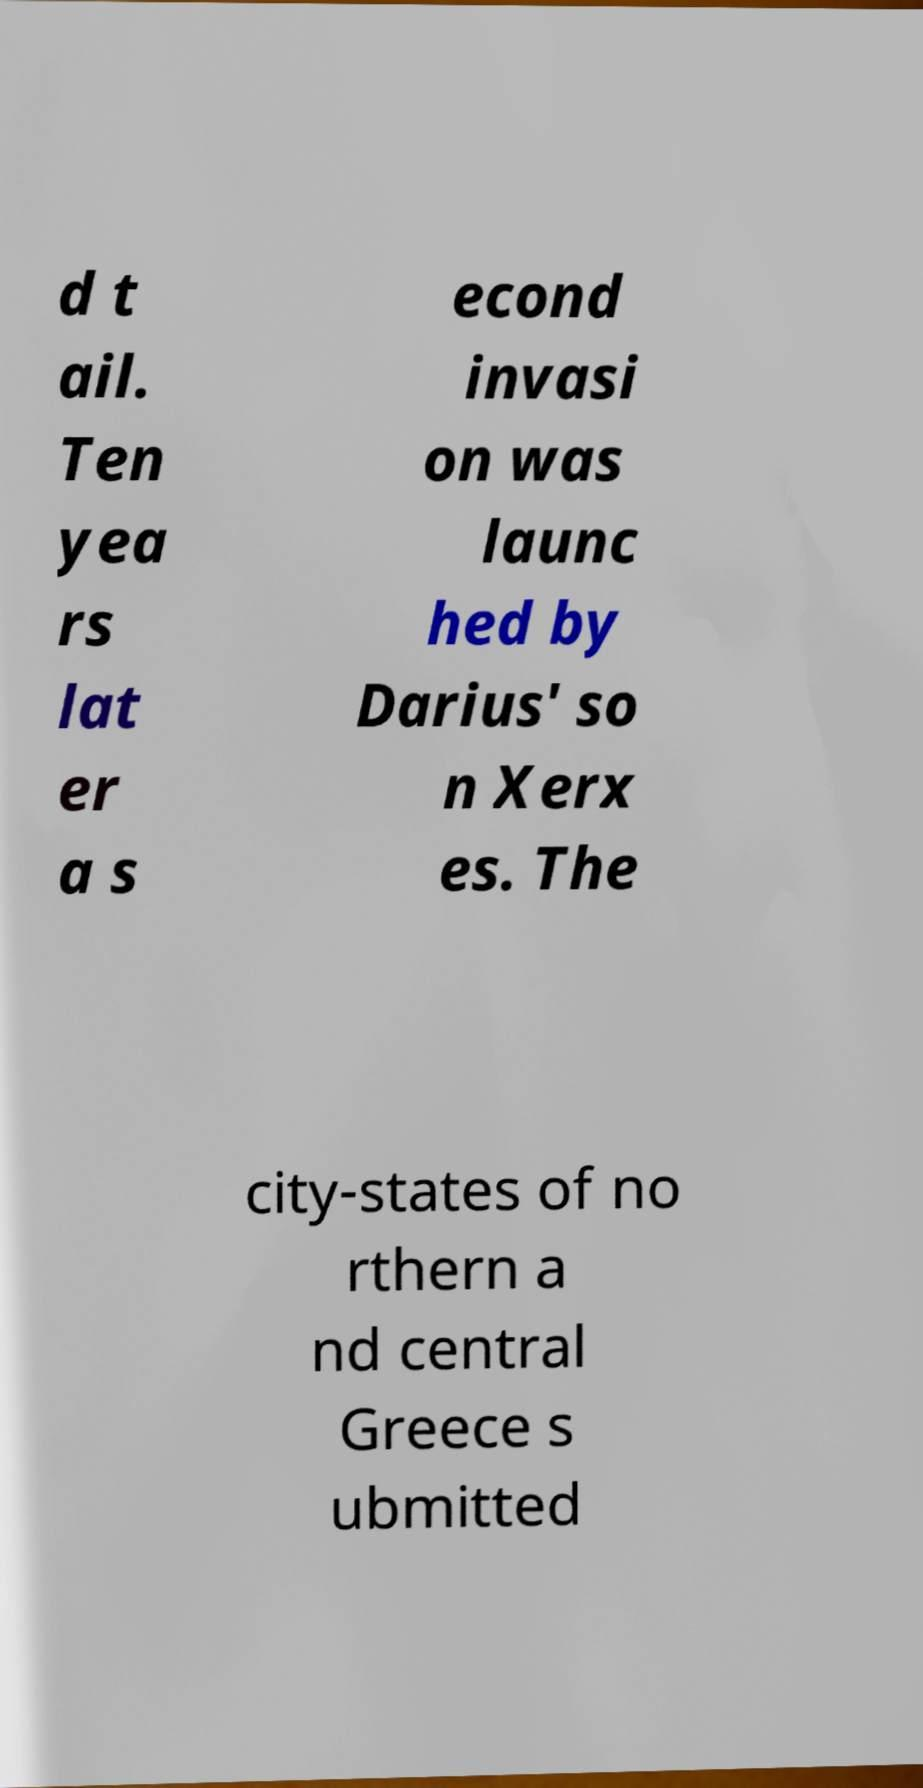What messages or text are displayed in this image? I need them in a readable, typed format. d t ail. Ten yea rs lat er a s econd invasi on was launc hed by Darius' so n Xerx es. The city-states of no rthern a nd central Greece s ubmitted 